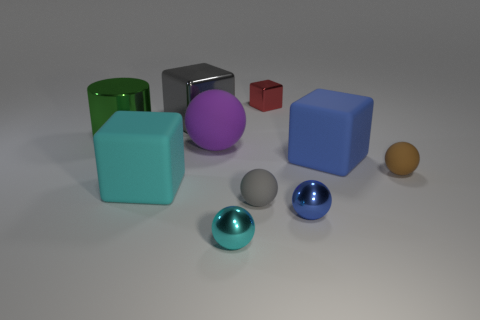Subtract 2 blocks. How many blocks are left? 2 Subtract all red cubes. How many cubes are left? 3 Subtract all big purple matte spheres. How many spheres are left? 4 Subtract all green blocks. Subtract all brown cylinders. How many blocks are left? 4 Subtract all cylinders. How many objects are left? 9 Add 10 gray shiny spheres. How many gray shiny spheres exist? 10 Subtract 1 brown spheres. How many objects are left? 9 Subtract all tiny blue things. Subtract all large cyan objects. How many objects are left? 8 Add 6 big metal things. How many big metal things are left? 8 